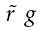Convert formula to latex. <formula><loc_0><loc_0><loc_500><loc_500>\begin{smallmatrix} \tilde { r } & g \end{smallmatrix}</formula> 